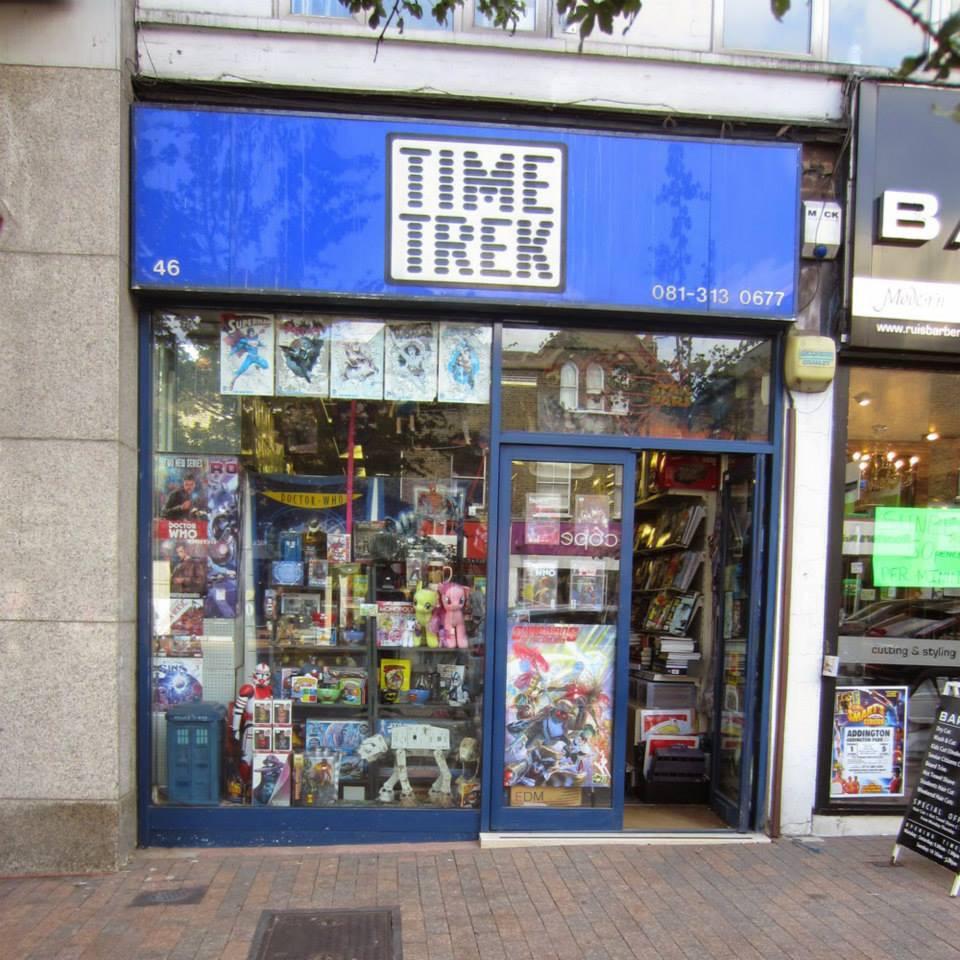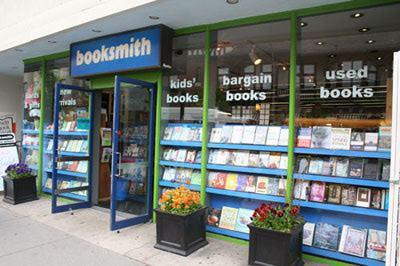The first image is the image on the left, the second image is the image on the right. Analyze the images presented: Is the assertion "An image shows multiple non-hanging containers of flowering plants in front of a shop's exterior." valid? Answer yes or no. Yes. The first image is the image on the left, the second image is the image on the right. For the images displayed, is the sentence "Both images shown the exterior of a bookstore." factually correct? Answer yes or no. Yes. 